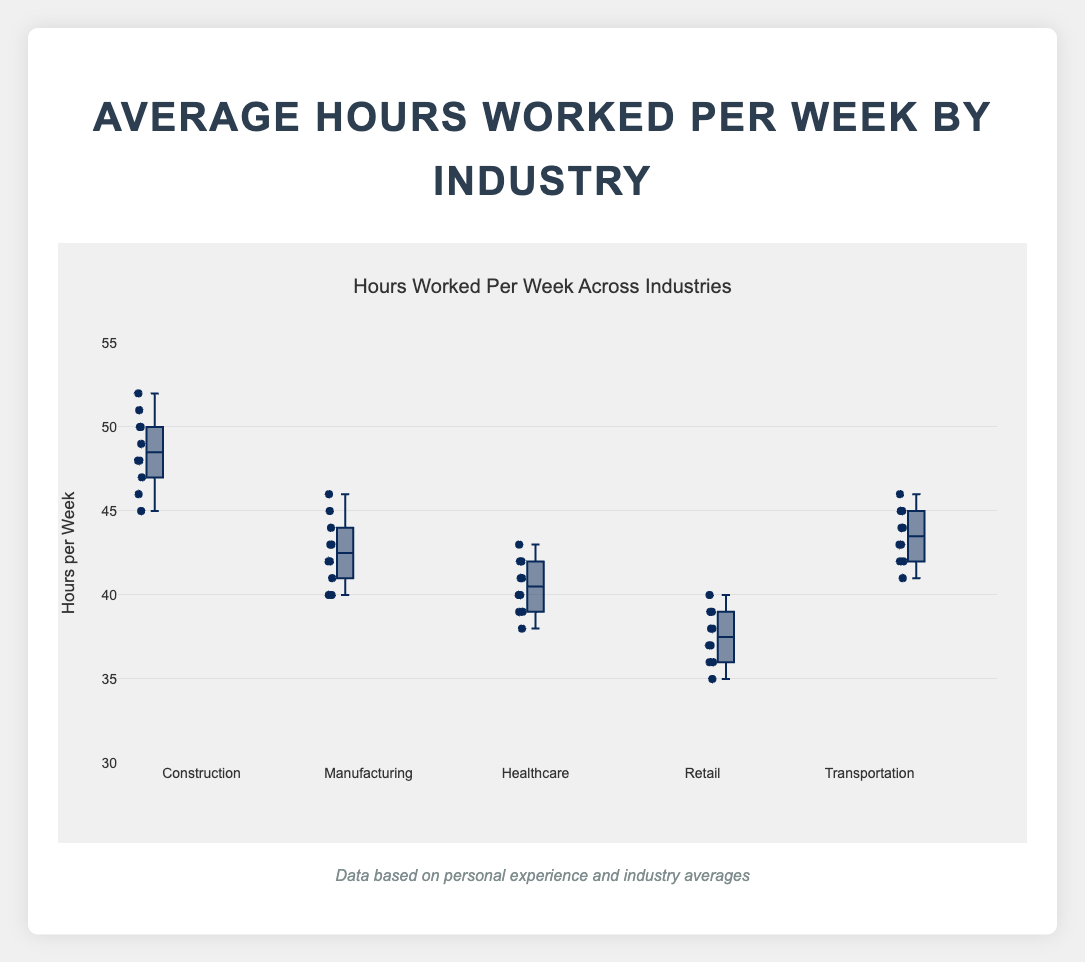What's the title of the plot? The title of the plot is shown at the top, and it reads "Hours Worked Per Week Across Industries."
Answer: Hours Worked Per Week Across Industries How many industries are displayed in the box plot? There are labels along the x-axis, each representing a different industry. Counting these labels, we see five industries are displayed.
Answer: Five Which industry has the highest median value for hours worked per week? In a box plot, the median is indicated by the line inside the box. By observing the median lines, "Construction" has the highest median.
Answer: Construction What is the range of hours worked per week in the Retail industry? The range can be found by subtracting the minimum value from the maximum value. For Retail, the lowest value is 35, and the highest is 40. Thus, the range is 40 - 35.
Answer: 5 Which industry has the largest spread (interquartile range) of hours worked per week? The interquartile range (IQR) is the distance between the first quartile (Q1) and the third quartile (Q3). In the plot, "Construction" shows the largest spread between Q1 and Q3.
Answer: Construction Compare the average hours worked in Manufacturing and Healthcare. Which is higher? Visually, the box plot's mean is indicated by the points (if shown) or can be approximated by looking at the median if both are symmetrical. By rough estimate, both look similar; however, detailed values for calculation would confirm it.
Answer: Manufacturing Is there any outlier in the Construction industry? If yes, what is it? Outliers in a box plot are shown as individual points that fall beyond the whiskers. Observing the Construction plot, there is no outlier displayed.
Answer: No What is the minimum value of hours worked per week in the Transportation industry? The minimum value in a box plot is indicated by the end of the lower whisker. For Transportation, this value is 41.
Answer: 41 Which industry has the most consistent working hours per week? Consistency can be interpreted by the tightness of the box and whiskers. "Retail" appears the most consistent as it has the smallest spread.
Answer: Retail 